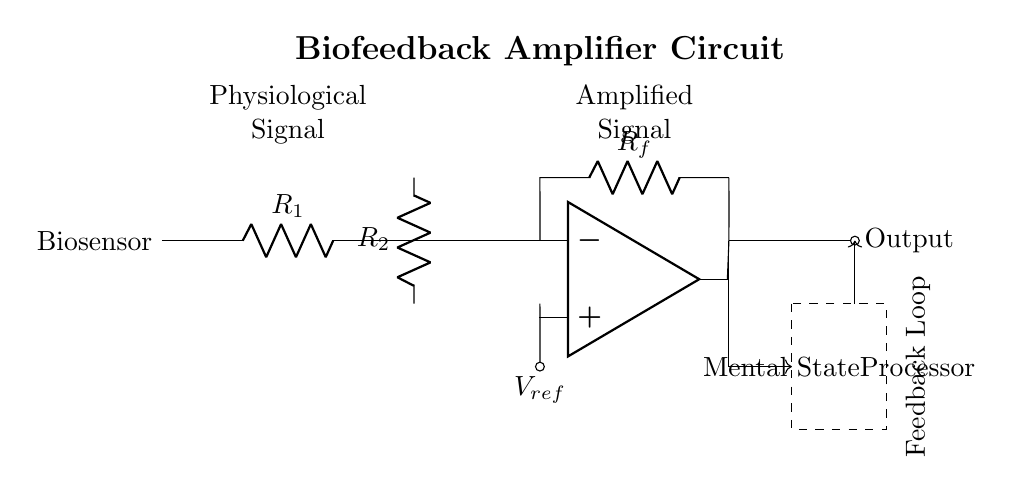What is the output of the amplifier? The output of the amplifier is represented at the right end of the circuit diagram, labeled as "Output". This indicates where the amplified signal is delivered from the circuit.
Answer: Output What is the function of R1? R1 is a resistor connected directly after the biosensor, which typically acts as a filter or part of a voltage divider to condition the input signal.
Answer: Resistor What does the dashed rectangle contain? The dashed rectangle signifies a specific section of the circuit dedicated to processing mental states, labeled as "Mental State Processor". It indicates that this part of the circuit is where further analysis of the mental states will occur.
Answer: Mental State Processor What type of feedback is used in this circuit? The feedback in this circuit is negative, as indicated by the configuration of the feedback loop returning to the non-inverting terminal of the operational amplifier. Negative feedback is commonly used to stabilize and control the gain of the amplifier.
Answer: Negative feedback What are the components connected to the inverting terminal of the op-amp? The components connected to the inverting terminal are the feedback resistor Rf and the output of the op-amp. The feedback loop from the output to the inverting terminal stabilizes amplification.
Answer: Rf and Output How many resistors are present in the circuit? The circuit contains two resistors: R1 and R2. These resistors are critical for conditioning the input signal and setting the gain of the amplifier.
Answer: Two 